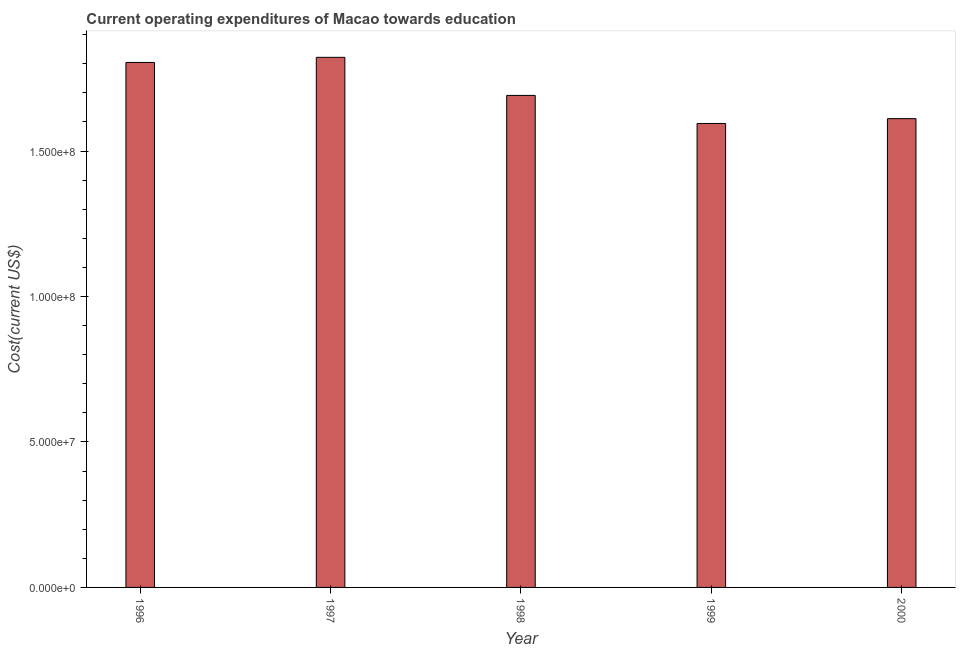Does the graph contain any zero values?
Your answer should be compact. No. Does the graph contain grids?
Your answer should be very brief. No. What is the title of the graph?
Your answer should be compact. Current operating expenditures of Macao towards education. What is the label or title of the X-axis?
Your answer should be compact. Year. What is the label or title of the Y-axis?
Make the answer very short. Cost(current US$). What is the education expenditure in 1996?
Provide a short and direct response. 1.80e+08. Across all years, what is the maximum education expenditure?
Make the answer very short. 1.82e+08. Across all years, what is the minimum education expenditure?
Provide a succinct answer. 1.59e+08. In which year was the education expenditure maximum?
Ensure brevity in your answer.  1997. In which year was the education expenditure minimum?
Your response must be concise. 1999. What is the sum of the education expenditure?
Keep it short and to the point. 8.52e+08. What is the difference between the education expenditure in 1996 and 2000?
Your answer should be very brief. 1.93e+07. What is the average education expenditure per year?
Your response must be concise. 1.70e+08. What is the median education expenditure?
Ensure brevity in your answer.  1.69e+08. In how many years, is the education expenditure greater than 30000000 US$?
Your answer should be compact. 5. What is the ratio of the education expenditure in 1997 to that in 1998?
Make the answer very short. 1.08. Is the difference between the education expenditure in 1996 and 1997 greater than the difference between any two years?
Provide a short and direct response. No. What is the difference between the highest and the second highest education expenditure?
Give a very brief answer. 1.76e+06. Is the sum of the education expenditure in 1997 and 2000 greater than the maximum education expenditure across all years?
Provide a succinct answer. Yes. What is the difference between the highest and the lowest education expenditure?
Provide a succinct answer. 2.27e+07. In how many years, is the education expenditure greater than the average education expenditure taken over all years?
Offer a terse response. 2. Are all the bars in the graph horizontal?
Offer a terse response. No. Are the values on the major ticks of Y-axis written in scientific E-notation?
Make the answer very short. Yes. What is the Cost(current US$) of 1996?
Ensure brevity in your answer.  1.80e+08. What is the Cost(current US$) in 1997?
Your answer should be very brief. 1.82e+08. What is the Cost(current US$) of 1998?
Your answer should be very brief. 1.69e+08. What is the Cost(current US$) of 1999?
Ensure brevity in your answer.  1.59e+08. What is the Cost(current US$) of 2000?
Provide a short and direct response. 1.61e+08. What is the difference between the Cost(current US$) in 1996 and 1997?
Offer a very short reply. -1.76e+06. What is the difference between the Cost(current US$) in 1996 and 1998?
Provide a short and direct response. 1.13e+07. What is the difference between the Cost(current US$) in 1996 and 1999?
Provide a short and direct response. 2.10e+07. What is the difference between the Cost(current US$) in 1996 and 2000?
Your response must be concise. 1.93e+07. What is the difference between the Cost(current US$) in 1997 and 1998?
Your answer should be very brief. 1.31e+07. What is the difference between the Cost(current US$) in 1997 and 1999?
Your response must be concise. 2.27e+07. What is the difference between the Cost(current US$) in 1997 and 2000?
Provide a succinct answer. 2.11e+07. What is the difference between the Cost(current US$) in 1998 and 1999?
Make the answer very short. 9.65e+06. What is the difference between the Cost(current US$) in 1998 and 2000?
Your response must be concise. 7.99e+06. What is the difference between the Cost(current US$) in 1999 and 2000?
Give a very brief answer. -1.66e+06. What is the ratio of the Cost(current US$) in 1996 to that in 1998?
Offer a very short reply. 1.07. What is the ratio of the Cost(current US$) in 1996 to that in 1999?
Your response must be concise. 1.13. What is the ratio of the Cost(current US$) in 1996 to that in 2000?
Provide a succinct answer. 1.12. What is the ratio of the Cost(current US$) in 1997 to that in 1998?
Your answer should be very brief. 1.08. What is the ratio of the Cost(current US$) in 1997 to that in 1999?
Keep it short and to the point. 1.14. What is the ratio of the Cost(current US$) in 1997 to that in 2000?
Provide a succinct answer. 1.13. What is the ratio of the Cost(current US$) in 1998 to that in 1999?
Make the answer very short. 1.06. 